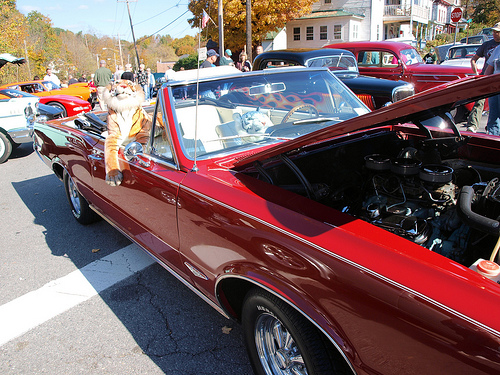<image>
Can you confirm if the sign is behind the car? Yes. From this viewpoint, the sign is positioned behind the car, with the car partially or fully occluding the sign. 